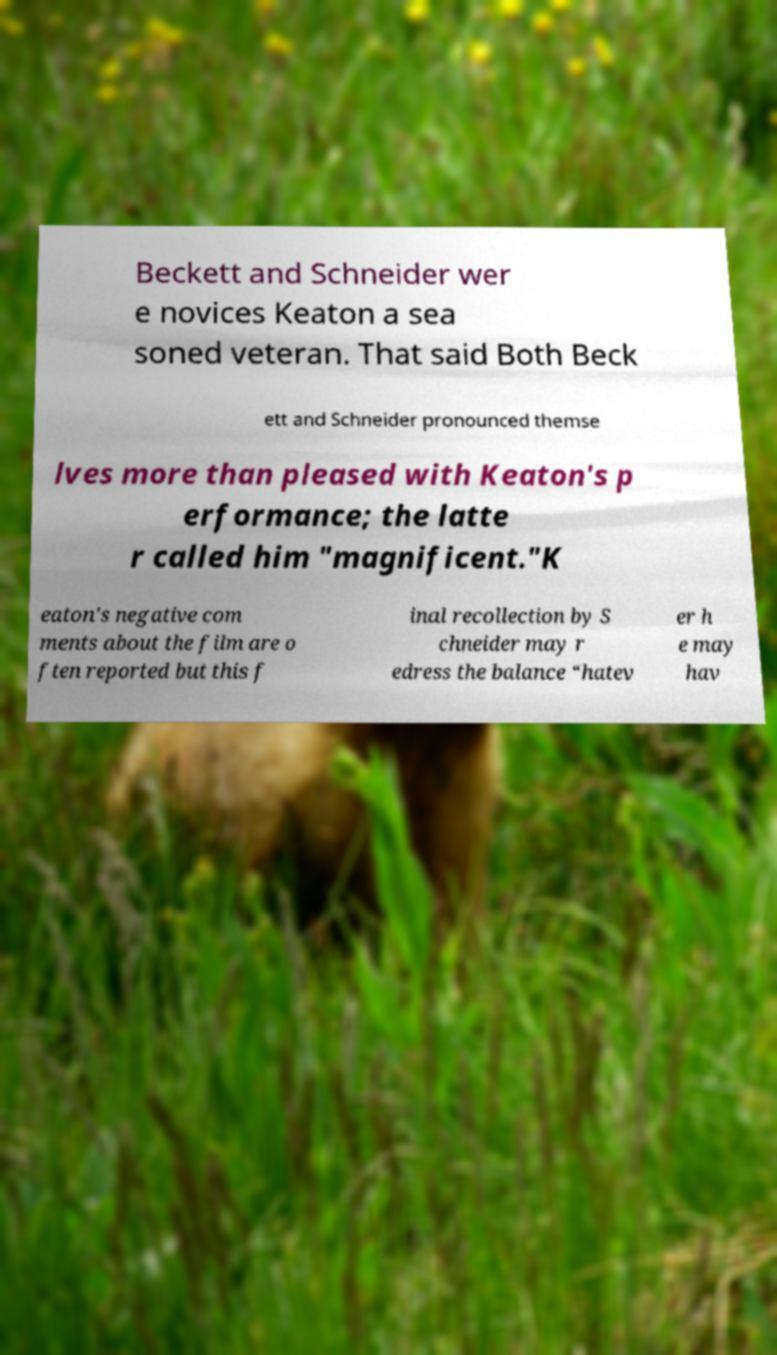Can you read and provide the text displayed in the image?This photo seems to have some interesting text. Can you extract and type it out for me? Beckett and Schneider wer e novices Keaton a sea soned veteran. That said Both Beck ett and Schneider pronounced themse lves more than pleased with Keaton's p erformance; the latte r called him "magnificent."K eaton's negative com ments about the film are o ften reported but this f inal recollection by S chneider may r edress the balance “hatev er h e may hav 